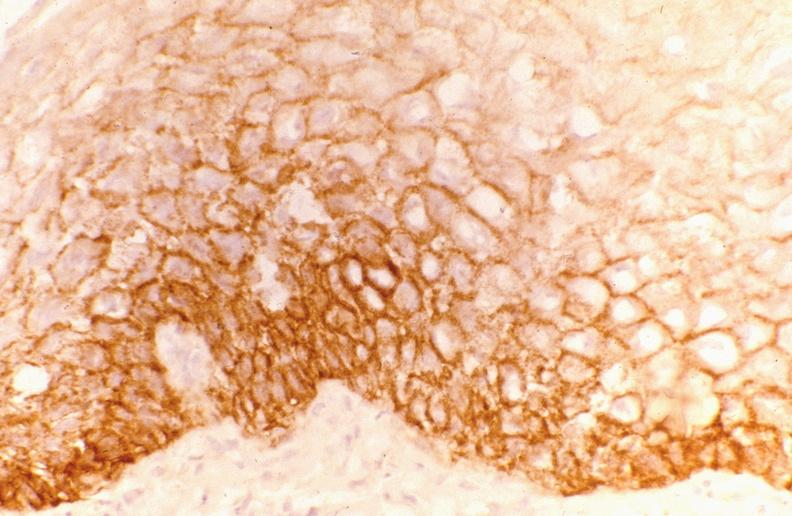does normal newborn show leukoplakia, egf receptor?
Answer the question using a single word or phrase. No 